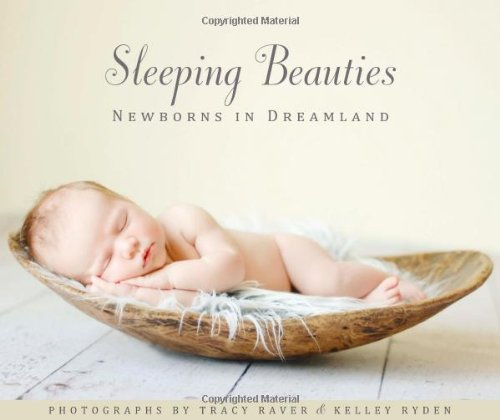Who wrote this book? The book 'Sleeping Beauties: Newborns in Dreamland' was co-authored by Tracy Raver and Kelley Ryden. 